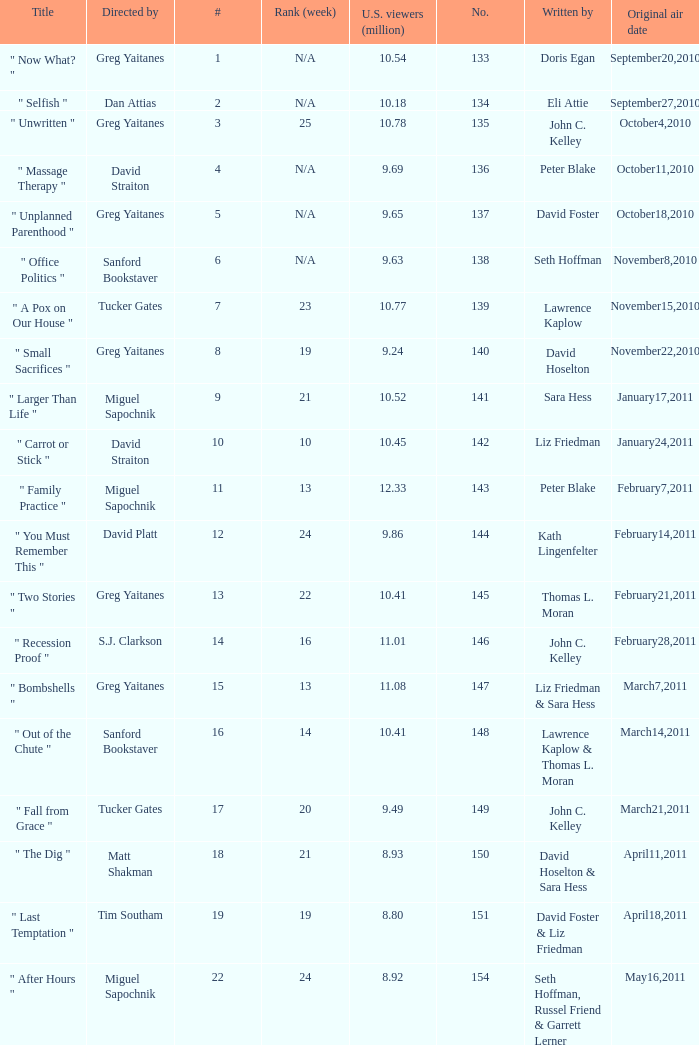How many episodes were written by seth hoffman, russel friend & garrett lerner? 1.0. 